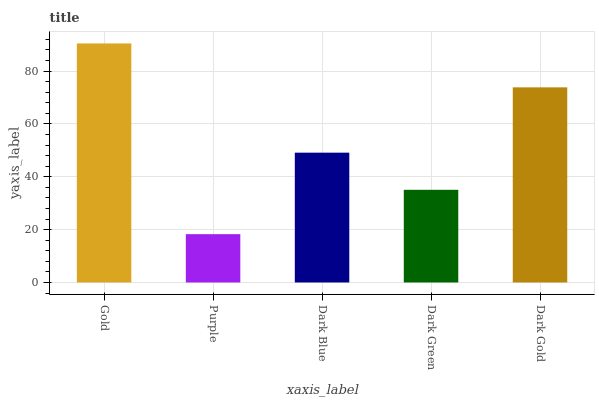Is Purple the minimum?
Answer yes or no. Yes. Is Gold the maximum?
Answer yes or no. Yes. Is Dark Blue the minimum?
Answer yes or no. No. Is Dark Blue the maximum?
Answer yes or no. No. Is Dark Blue greater than Purple?
Answer yes or no. Yes. Is Purple less than Dark Blue?
Answer yes or no. Yes. Is Purple greater than Dark Blue?
Answer yes or no. No. Is Dark Blue less than Purple?
Answer yes or no. No. Is Dark Blue the high median?
Answer yes or no. Yes. Is Dark Blue the low median?
Answer yes or no. Yes. Is Gold the high median?
Answer yes or no. No. Is Dark Green the low median?
Answer yes or no. No. 